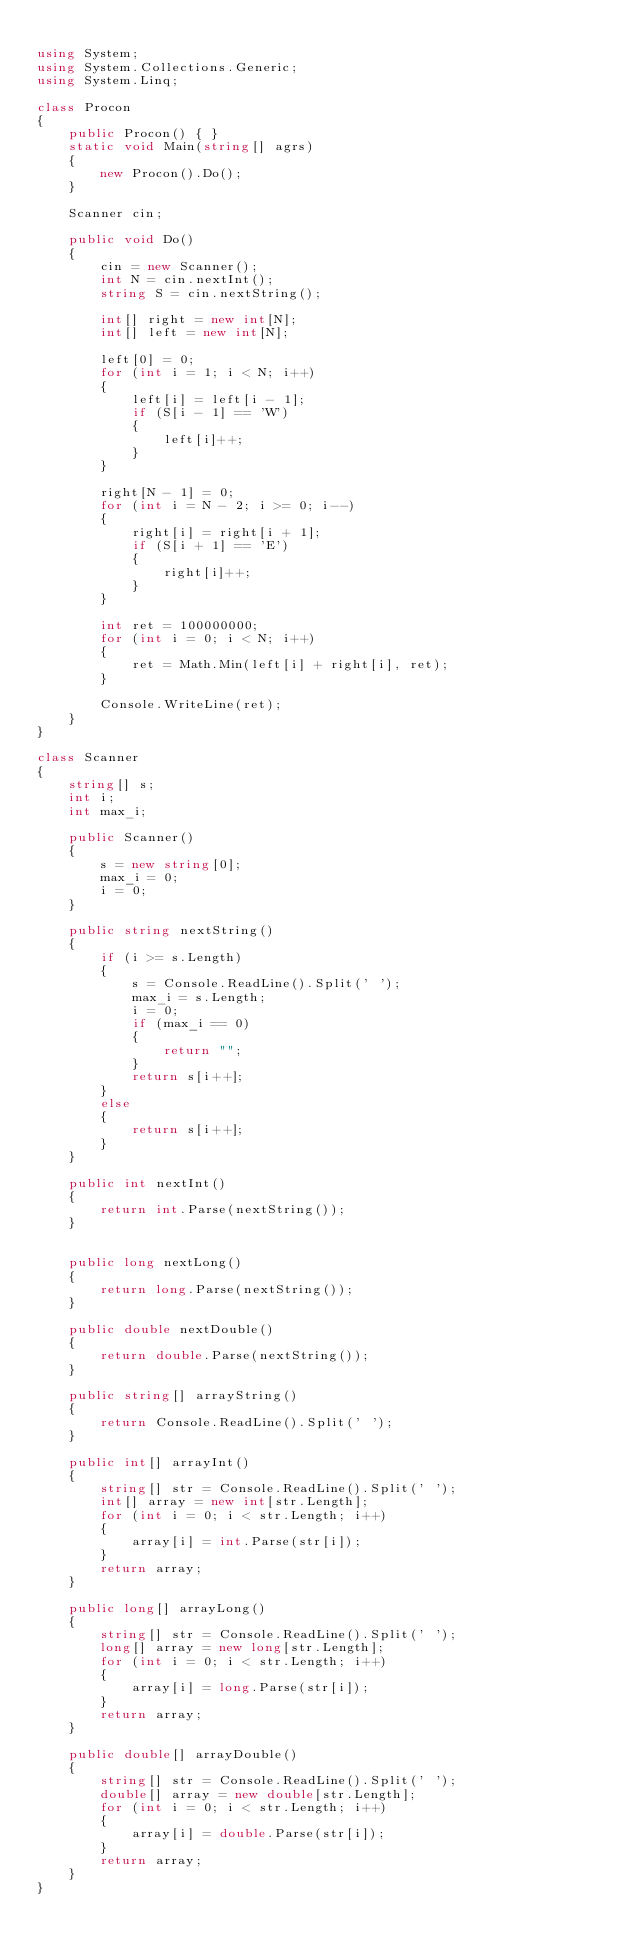Convert code to text. <code><loc_0><loc_0><loc_500><loc_500><_C#_>
using System;
using System.Collections.Generic;
using System.Linq;

class Procon
{
    public Procon() { }
    static void Main(string[] agrs)
    {
        new Procon().Do();
    }

    Scanner cin;

    public void Do()
    {
        cin = new Scanner();
        int N = cin.nextInt();
        string S = cin.nextString();

        int[] right = new int[N];
        int[] left = new int[N];

        left[0] = 0;
        for (int i = 1; i < N; i++)
        {
            left[i] = left[i - 1];
            if (S[i - 1] == 'W')
            {
                left[i]++;
            }
        }

        right[N - 1] = 0;
        for (int i = N - 2; i >= 0; i--)
        {
            right[i] = right[i + 1];
            if (S[i + 1] == 'E')
            {
                right[i]++;
            }
        }

        int ret = 100000000;
        for (int i = 0; i < N; i++)
        {
            ret = Math.Min(left[i] + right[i], ret);
        }

        Console.WriteLine(ret);
    }
}

class Scanner
{
    string[] s;
    int i;
    int max_i;

    public Scanner()
    {
        s = new string[0];
        max_i = 0;
        i = 0;
    }

    public string nextString()
    {
        if (i >= s.Length)
        {
            s = Console.ReadLine().Split(' ');
            max_i = s.Length;
            i = 0;
            if (max_i == 0)
            {
                return "";
            }
            return s[i++];
        }
        else
        {
            return s[i++];
        }
    }

    public int nextInt()
    {
        return int.Parse(nextString());
    }


    public long nextLong()
    {
        return long.Parse(nextString());
    }

    public double nextDouble()
    {
        return double.Parse(nextString());
    }

    public string[] arrayString()
    {
        return Console.ReadLine().Split(' ');
    }

    public int[] arrayInt()
    {
        string[] str = Console.ReadLine().Split(' ');
        int[] array = new int[str.Length];
        for (int i = 0; i < str.Length; i++)
        {
            array[i] = int.Parse(str[i]);
        }
        return array;
    }

    public long[] arrayLong()
    {
        string[] str = Console.ReadLine().Split(' ');
        long[] array = new long[str.Length];
        for (int i = 0; i < str.Length; i++)
        {
            array[i] = long.Parse(str[i]);
        }
        return array;
    }

    public double[] arrayDouble()
    {
        string[] str = Console.ReadLine().Split(' ');
        double[] array = new double[str.Length];
        for (int i = 0; i < str.Length; i++)
        {
            array[i] = double.Parse(str[i]);
        }
        return array;
    }
}</code> 